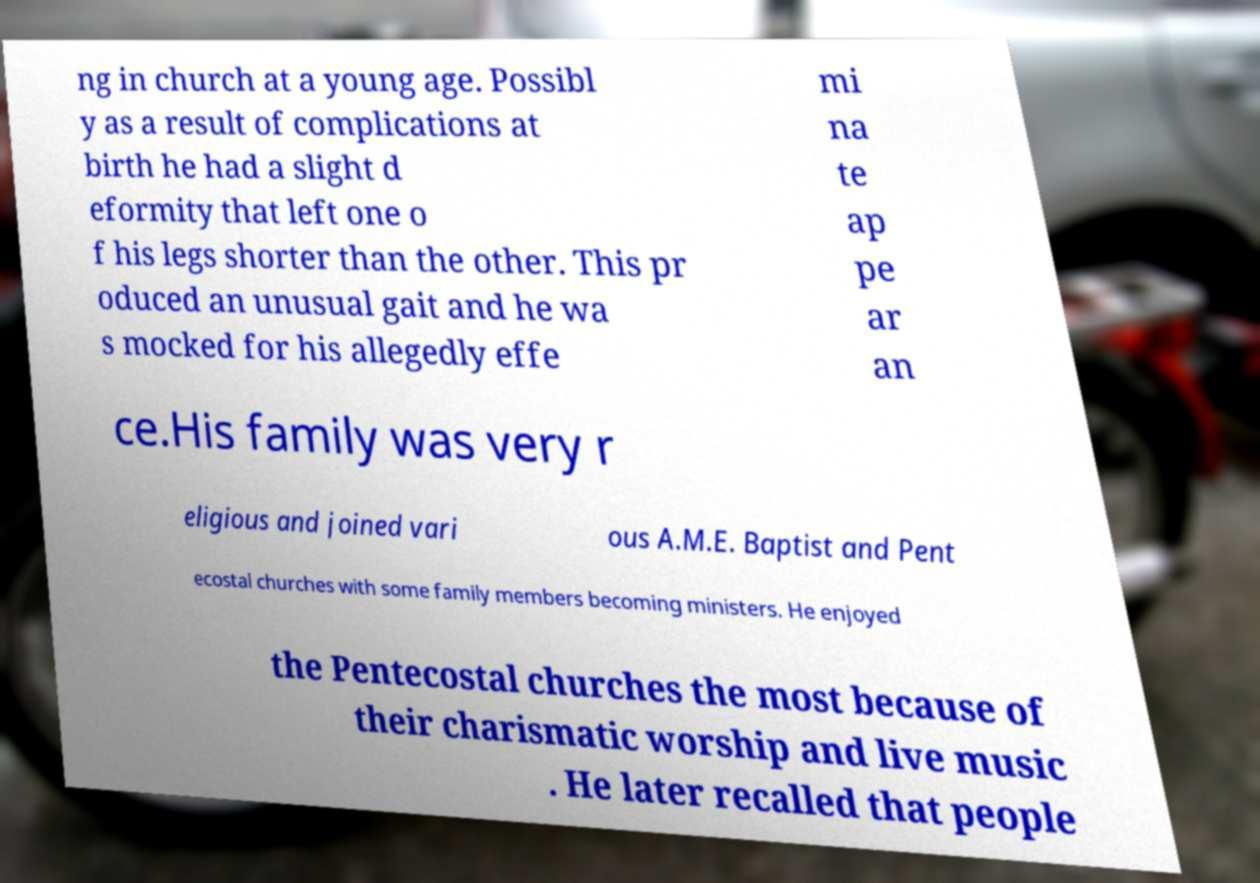Please read and relay the text visible in this image. What does it say? ng in church at a young age. Possibl y as a result of complications at birth he had a slight d eformity that left one o f his legs shorter than the other. This pr oduced an unusual gait and he wa s mocked for his allegedly effe mi na te ap pe ar an ce.His family was very r eligious and joined vari ous A.M.E. Baptist and Pent ecostal churches with some family members becoming ministers. He enjoyed the Pentecostal churches the most because of their charismatic worship and live music . He later recalled that people 